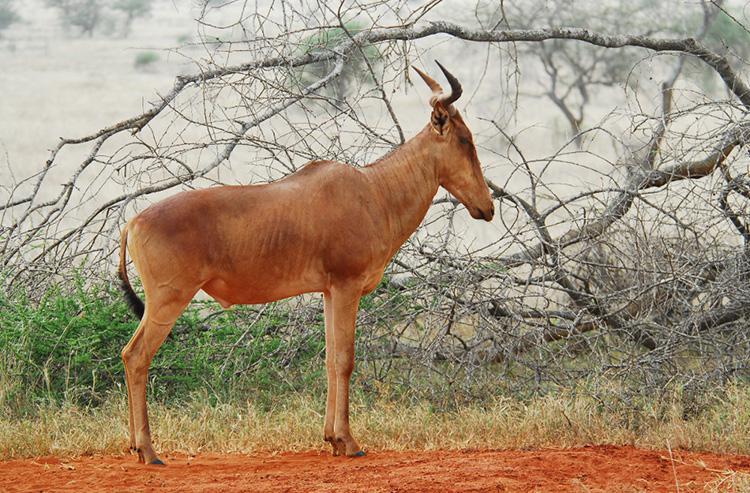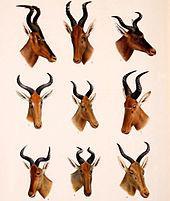The first image is the image on the left, the second image is the image on the right. Evaluate the accuracy of this statement regarding the images: "The right image shows more than one antelope-type animal.". Is it true? Answer yes or no. Yes. The first image is the image on the left, the second image is the image on the right. Examine the images to the left and right. Is the description "There are more animals in the image on the right than on the left." accurate? Answer yes or no. Yes. 